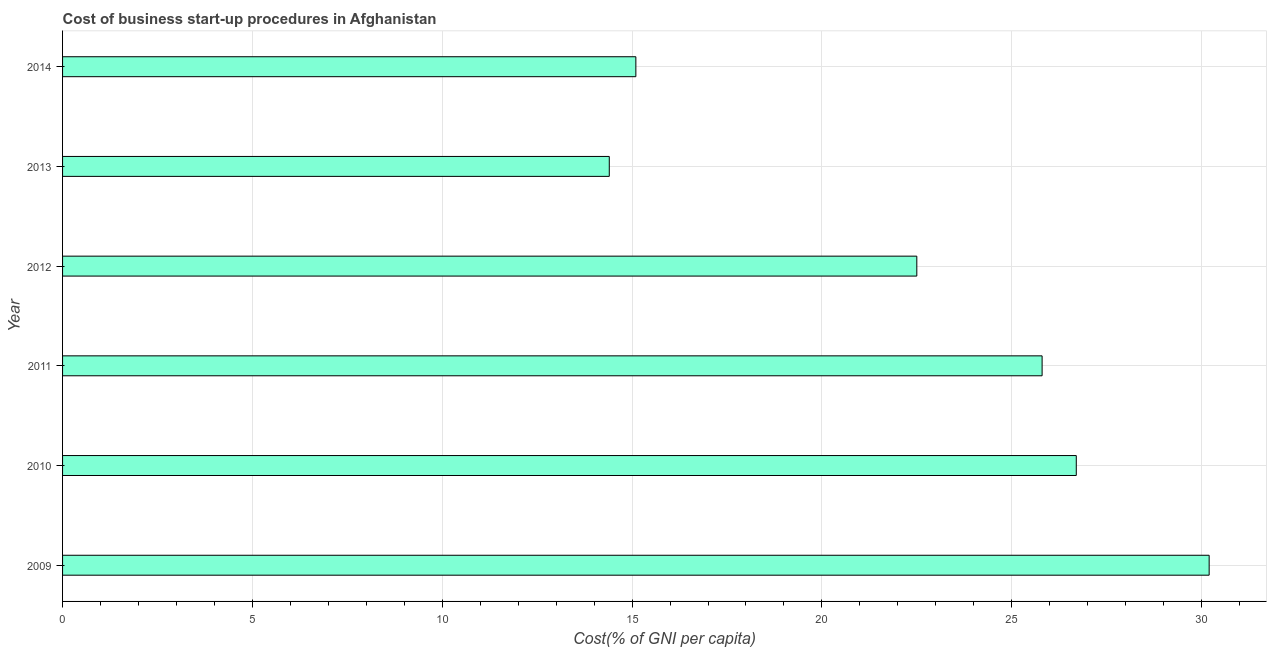What is the title of the graph?
Provide a short and direct response. Cost of business start-up procedures in Afghanistan. What is the label or title of the X-axis?
Your answer should be compact. Cost(% of GNI per capita). What is the label or title of the Y-axis?
Offer a very short reply. Year. Across all years, what is the maximum cost of business startup procedures?
Your answer should be compact. 30.2. In which year was the cost of business startup procedures maximum?
Offer a terse response. 2009. In which year was the cost of business startup procedures minimum?
Ensure brevity in your answer.  2013. What is the sum of the cost of business startup procedures?
Provide a short and direct response. 134.7. What is the average cost of business startup procedures per year?
Offer a very short reply. 22.45. What is the median cost of business startup procedures?
Provide a short and direct response. 24.15. Do a majority of the years between 2010 and 2013 (inclusive) have cost of business startup procedures greater than 27 %?
Offer a terse response. No. What is the ratio of the cost of business startup procedures in 2010 to that in 2011?
Ensure brevity in your answer.  1.03. Is the difference between the cost of business startup procedures in 2013 and 2014 greater than the difference between any two years?
Make the answer very short. No. How many bars are there?
Provide a short and direct response. 6. What is the Cost(% of GNI per capita) in 2009?
Make the answer very short. 30.2. What is the Cost(% of GNI per capita) in 2010?
Your response must be concise. 26.7. What is the Cost(% of GNI per capita) in 2011?
Ensure brevity in your answer.  25.8. What is the Cost(% of GNI per capita) of 2012?
Offer a terse response. 22.5. What is the Cost(% of GNI per capita) of 2013?
Offer a terse response. 14.4. What is the difference between the Cost(% of GNI per capita) in 2009 and 2011?
Give a very brief answer. 4.4. What is the difference between the Cost(% of GNI per capita) in 2009 and 2013?
Your answer should be very brief. 15.8. What is the difference between the Cost(% of GNI per capita) in 2010 and 2011?
Your answer should be compact. 0.9. What is the difference between the Cost(% of GNI per capita) in 2012 and 2013?
Give a very brief answer. 8.1. What is the ratio of the Cost(% of GNI per capita) in 2009 to that in 2010?
Offer a terse response. 1.13. What is the ratio of the Cost(% of GNI per capita) in 2009 to that in 2011?
Provide a succinct answer. 1.17. What is the ratio of the Cost(% of GNI per capita) in 2009 to that in 2012?
Offer a very short reply. 1.34. What is the ratio of the Cost(% of GNI per capita) in 2009 to that in 2013?
Your answer should be compact. 2.1. What is the ratio of the Cost(% of GNI per capita) in 2009 to that in 2014?
Make the answer very short. 2. What is the ratio of the Cost(% of GNI per capita) in 2010 to that in 2011?
Your answer should be compact. 1.03. What is the ratio of the Cost(% of GNI per capita) in 2010 to that in 2012?
Offer a very short reply. 1.19. What is the ratio of the Cost(% of GNI per capita) in 2010 to that in 2013?
Offer a very short reply. 1.85. What is the ratio of the Cost(% of GNI per capita) in 2010 to that in 2014?
Your response must be concise. 1.77. What is the ratio of the Cost(% of GNI per capita) in 2011 to that in 2012?
Your answer should be very brief. 1.15. What is the ratio of the Cost(% of GNI per capita) in 2011 to that in 2013?
Give a very brief answer. 1.79. What is the ratio of the Cost(% of GNI per capita) in 2011 to that in 2014?
Keep it short and to the point. 1.71. What is the ratio of the Cost(% of GNI per capita) in 2012 to that in 2013?
Ensure brevity in your answer.  1.56. What is the ratio of the Cost(% of GNI per capita) in 2012 to that in 2014?
Your response must be concise. 1.49. What is the ratio of the Cost(% of GNI per capita) in 2013 to that in 2014?
Make the answer very short. 0.95. 